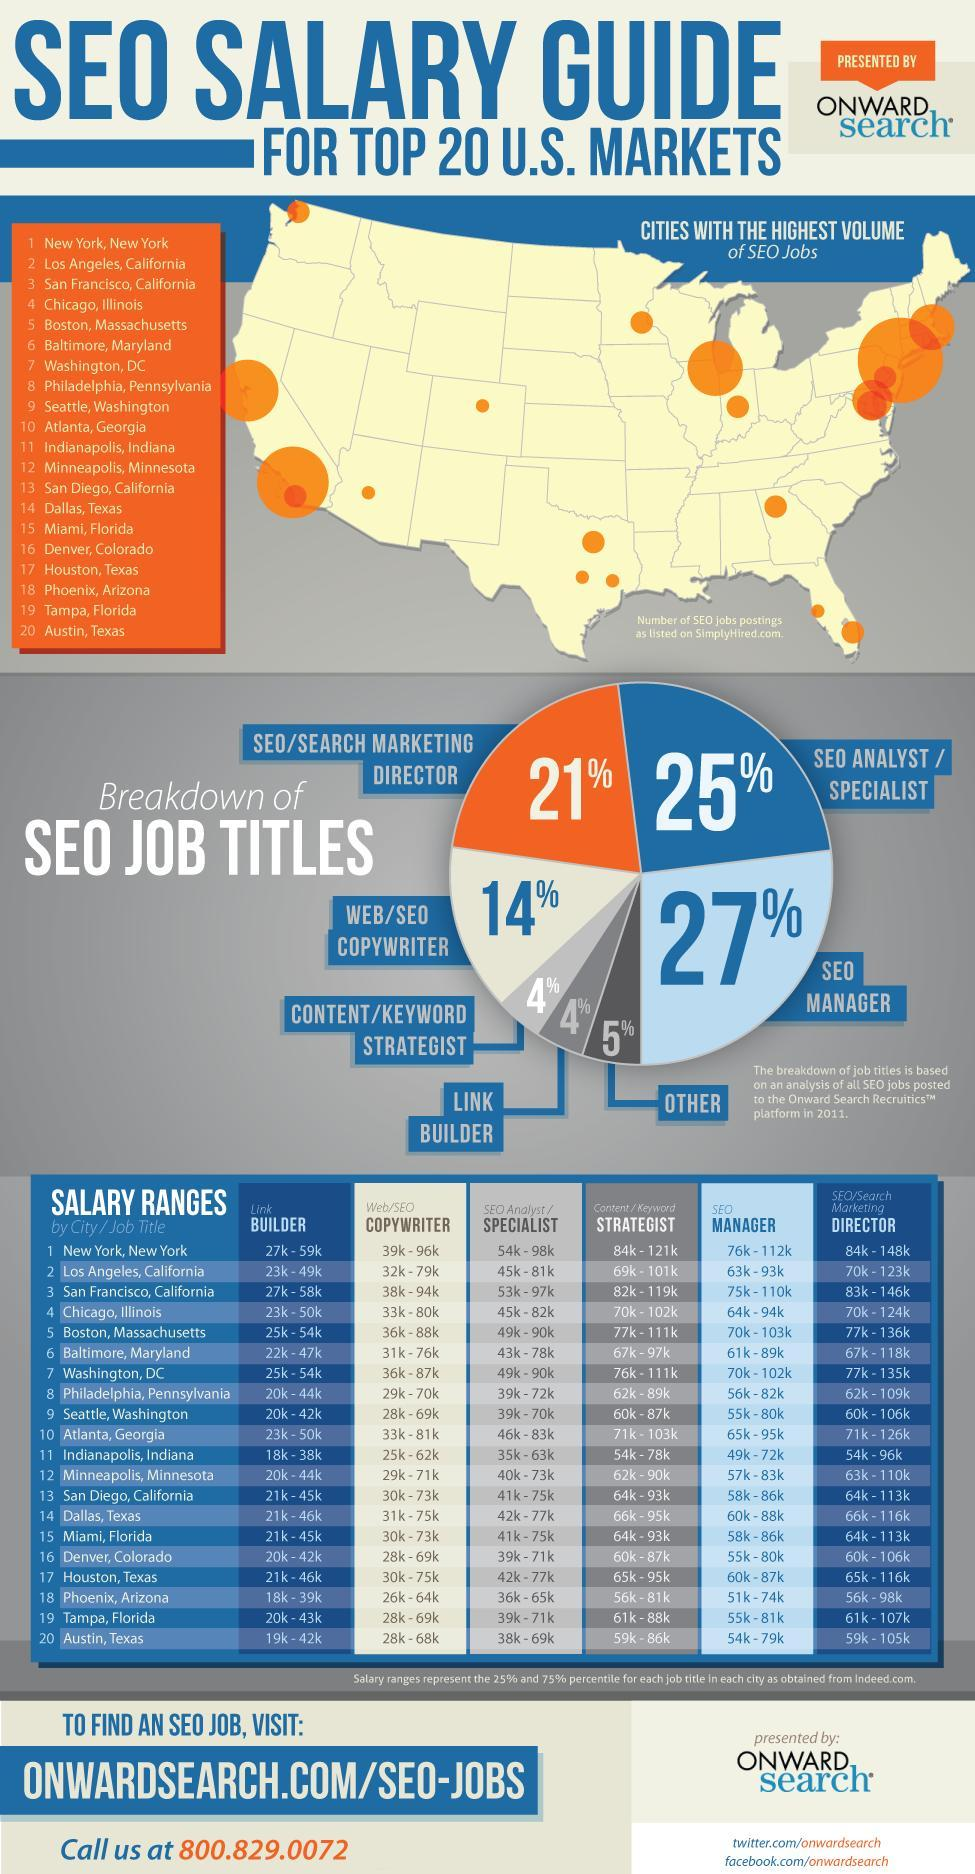Which role or job title is specified in the first row and fourth column?
Answer the question with a short phrase. SEO Analyst/ Specialist What is the salary range of link builders in Seattle and Denver ? 20k - 42k Which state appears as the least paid category for the role of Strategist? Indianapolis, Indiana Which place pays the fourth highest salary range for Director ? Atlanta, Georgia Which state tops the list of SEO jobs? New York What percentage of people work as content strategist or link builders? 4% How many items are listed in the table? 7 